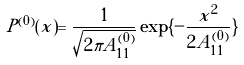<formula> <loc_0><loc_0><loc_500><loc_500>P ^ { ( 0 ) } ( x ) = \frac { 1 } { \sqrt { 2 \pi A _ { 1 1 } ^ { ( 0 ) } } } \exp \{ - \frac { x ^ { 2 } } { 2 A _ { 1 1 } ^ { ( 0 ) } } \}</formula> 